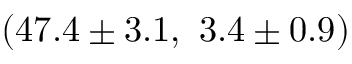<formula> <loc_0><loc_0><loc_500><loc_500>( 4 7 . 4 \pm 3 . 1 , \ 3 . 4 \pm 0 . 9 )</formula> 